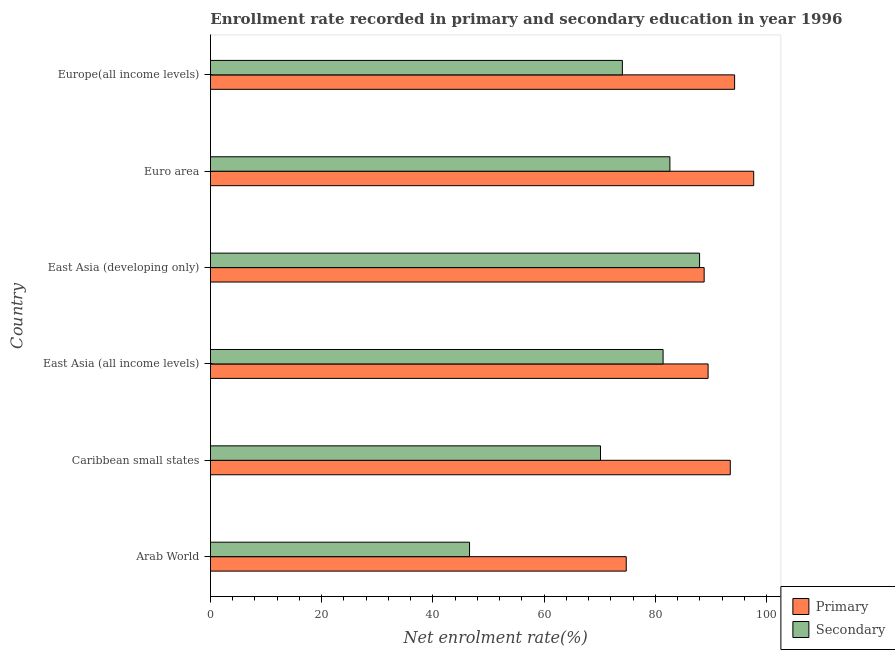Are the number of bars per tick equal to the number of legend labels?
Your answer should be very brief. Yes. How many bars are there on the 1st tick from the top?
Offer a terse response. 2. What is the label of the 3rd group of bars from the top?
Provide a short and direct response. East Asia (developing only). In how many cases, is the number of bars for a given country not equal to the number of legend labels?
Provide a succinct answer. 0. What is the enrollment rate in primary education in Caribbean small states?
Provide a succinct answer. 93.46. Across all countries, what is the maximum enrollment rate in secondary education?
Offer a terse response. 87.94. Across all countries, what is the minimum enrollment rate in primary education?
Make the answer very short. 74.76. In which country was the enrollment rate in secondary education maximum?
Your response must be concise. East Asia (developing only). In which country was the enrollment rate in primary education minimum?
Ensure brevity in your answer.  Arab World. What is the total enrollment rate in primary education in the graph?
Keep it short and to the point. 538.38. What is the difference between the enrollment rate in primary education in East Asia (developing only) and that in Euro area?
Your answer should be compact. -8.91. What is the difference between the enrollment rate in primary education in Euro area and the enrollment rate in secondary education in Europe(all income levels)?
Provide a succinct answer. 23.62. What is the average enrollment rate in secondary education per country?
Offer a terse response. 73.78. What is the difference between the enrollment rate in primary education and enrollment rate in secondary education in Arab World?
Provide a short and direct response. 28.18. In how many countries, is the enrollment rate in primary education greater than 40 %?
Offer a very short reply. 6. What is the ratio of the enrollment rate in primary education in East Asia (all income levels) to that in East Asia (developing only)?
Ensure brevity in your answer.  1.01. Is the enrollment rate in primary education in Arab World less than that in East Asia (developing only)?
Make the answer very short. Yes. What is the difference between the highest and the second highest enrollment rate in secondary education?
Offer a terse response. 5.34. What is the difference between the highest and the lowest enrollment rate in secondary education?
Make the answer very short. 41.36. What does the 2nd bar from the top in Arab World represents?
Offer a very short reply. Primary. What does the 2nd bar from the bottom in Arab World represents?
Your answer should be compact. Secondary. How many bars are there?
Make the answer very short. 12. Are all the bars in the graph horizontal?
Your answer should be compact. Yes. How many countries are there in the graph?
Ensure brevity in your answer.  6. What is the difference between two consecutive major ticks on the X-axis?
Make the answer very short. 20. Are the values on the major ticks of X-axis written in scientific E-notation?
Your response must be concise. No. Does the graph contain grids?
Make the answer very short. No. Where does the legend appear in the graph?
Your answer should be very brief. Bottom right. How many legend labels are there?
Provide a succinct answer. 2. How are the legend labels stacked?
Give a very brief answer. Vertical. What is the title of the graph?
Offer a very short reply. Enrollment rate recorded in primary and secondary education in year 1996. Does "Services" appear as one of the legend labels in the graph?
Offer a very short reply. No. What is the label or title of the X-axis?
Offer a very short reply. Net enrolment rate(%). What is the Net enrolment rate(%) in Primary in Arab World?
Provide a succinct answer. 74.76. What is the Net enrolment rate(%) of Secondary in Arab World?
Your response must be concise. 46.58. What is the Net enrolment rate(%) in Primary in Caribbean small states?
Ensure brevity in your answer.  93.46. What is the Net enrolment rate(%) in Secondary in Caribbean small states?
Your response must be concise. 70.13. What is the Net enrolment rate(%) in Primary in East Asia (all income levels)?
Your response must be concise. 89.47. What is the Net enrolment rate(%) in Secondary in East Asia (all income levels)?
Your answer should be compact. 81.38. What is the Net enrolment rate(%) in Primary in East Asia (developing only)?
Your answer should be very brief. 88.77. What is the Net enrolment rate(%) of Secondary in East Asia (developing only)?
Give a very brief answer. 87.94. What is the Net enrolment rate(%) of Primary in Euro area?
Your response must be concise. 97.68. What is the Net enrolment rate(%) of Secondary in Euro area?
Offer a terse response. 82.6. What is the Net enrolment rate(%) in Primary in Europe(all income levels)?
Ensure brevity in your answer.  94.24. What is the Net enrolment rate(%) in Secondary in Europe(all income levels)?
Ensure brevity in your answer.  74.06. Across all countries, what is the maximum Net enrolment rate(%) in Primary?
Give a very brief answer. 97.68. Across all countries, what is the maximum Net enrolment rate(%) of Secondary?
Give a very brief answer. 87.94. Across all countries, what is the minimum Net enrolment rate(%) of Primary?
Your response must be concise. 74.76. Across all countries, what is the minimum Net enrolment rate(%) of Secondary?
Keep it short and to the point. 46.58. What is the total Net enrolment rate(%) of Primary in the graph?
Your answer should be compact. 538.38. What is the total Net enrolment rate(%) of Secondary in the graph?
Your answer should be compact. 442.7. What is the difference between the Net enrolment rate(%) of Primary in Arab World and that in Caribbean small states?
Offer a very short reply. -18.7. What is the difference between the Net enrolment rate(%) of Secondary in Arab World and that in Caribbean small states?
Keep it short and to the point. -23.55. What is the difference between the Net enrolment rate(%) of Primary in Arab World and that in East Asia (all income levels)?
Your answer should be compact. -14.71. What is the difference between the Net enrolment rate(%) in Secondary in Arab World and that in East Asia (all income levels)?
Ensure brevity in your answer.  -34.8. What is the difference between the Net enrolment rate(%) of Primary in Arab World and that in East Asia (developing only)?
Your answer should be very brief. -14.01. What is the difference between the Net enrolment rate(%) of Secondary in Arab World and that in East Asia (developing only)?
Offer a terse response. -41.36. What is the difference between the Net enrolment rate(%) in Primary in Arab World and that in Euro area?
Your answer should be very brief. -22.92. What is the difference between the Net enrolment rate(%) of Secondary in Arab World and that in Euro area?
Keep it short and to the point. -36.02. What is the difference between the Net enrolment rate(%) in Primary in Arab World and that in Europe(all income levels)?
Your answer should be compact. -19.48. What is the difference between the Net enrolment rate(%) in Secondary in Arab World and that in Europe(all income levels)?
Make the answer very short. -27.48. What is the difference between the Net enrolment rate(%) of Primary in Caribbean small states and that in East Asia (all income levels)?
Keep it short and to the point. 3.99. What is the difference between the Net enrolment rate(%) in Secondary in Caribbean small states and that in East Asia (all income levels)?
Ensure brevity in your answer.  -11.25. What is the difference between the Net enrolment rate(%) of Primary in Caribbean small states and that in East Asia (developing only)?
Offer a terse response. 4.7. What is the difference between the Net enrolment rate(%) in Secondary in Caribbean small states and that in East Asia (developing only)?
Give a very brief answer. -17.82. What is the difference between the Net enrolment rate(%) in Primary in Caribbean small states and that in Euro area?
Keep it short and to the point. -4.21. What is the difference between the Net enrolment rate(%) in Secondary in Caribbean small states and that in Euro area?
Your answer should be compact. -12.48. What is the difference between the Net enrolment rate(%) in Primary in Caribbean small states and that in Europe(all income levels)?
Offer a very short reply. -0.78. What is the difference between the Net enrolment rate(%) in Secondary in Caribbean small states and that in Europe(all income levels)?
Your answer should be compact. -3.93. What is the difference between the Net enrolment rate(%) in Primary in East Asia (all income levels) and that in East Asia (developing only)?
Provide a short and direct response. 0.71. What is the difference between the Net enrolment rate(%) in Secondary in East Asia (all income levels) and that in East Asia (developing only)?
Your answer should be very brief. -6.56. What is the difference between the Net enrolment rate(%) of Primary in East Asia (all income levels) and that in Euro area?
Your answer should be very brief. -8.2. What is the difference between the Net enrolment rate(%) of Secondary in East Asia (all income levels) and that in Euro area?
Your answer should be compact. -1.22. What is the difference between the Net enrolment rate(%) in Primary in East Asia (all income levels) and that in Europe(all income levels)?
Provide a short and direct response. -4.77. What is the difference between the Net enrolment rate(%) in Secondary in East Asia (all income levels) and that in Europe(all income levels)?
Offer a terse response. 7.32. What is the difference between the Net enrolment rate(%) in Primary in East Asia (developing only) and that in Euro area?
Offer a very short reply. -8.91. What is the difference between the Net enrolment rate(%) of Secondary in East Asia (developing only) and that in Euro area?
Your response must be concise. 5.34. What is the difference between the Net enrolment rate(%) in Primary in East Asia (developing only) and that in Europe(all income levels)?
Your answer should be very brief. -5.48. What is the difference between the Net enrolment rate(%) in Secondary in East Asia (developing only) and that in Europe(all income levels)?
Keep it short and to the point. 13.88. What is the difference between the Net enrolment rate(%) in Primary in Euro area and that in Europe(all income levels)?
Ensure brevity in your answer.  3.43. What is the difference between the Net enrolment rate(%) in Secondary in Euro area and that in Europe(all income levels)?
Make the answer very short. 8.54. What is the difference between the Net enrolment rate(%) in Primary in Arab World and the Net enrolment rate(%) in Secondary in Caribbean small states?
Make the answer very short. 4.63. What is the difference between the Net enrolment rate(%) of Primary in Arab World and the Net enrolment rate(%) of Secondary in East Asia (all income levels)?
Keep it short and to the point. -6.62. What is the difference between the Net enrolment rate(%) in Primary in Arab World and the Net enrolment rate(%) in Secondary in East Asia (developing only)?
Your answer should be compact. -13.19. What is the difference between the Net enrolment rate(%) of Primary in Arab World and the Net enrolment rate(%) of Secondary in Euro area?
Give a very brief answer. -7.85. What is the difference between the Net enrolment rate(%) in Primary in Arab World and the Net enrolment rate(%) in Secondary in Europe(all income levels)?
Offer a very short reply. 0.7. What is the difference between the Net enrolment rate(%) in Primary in Caribbean small states and the Net enrolment rate(%) in Secondary in East Asia (all income levels)?
Offer a very short reply. 12.08. What is the difference between the Net enrolment rate(%) in Primary in Caribbean small states and the Net enrolment rate(%) in Secondary in East Asia (developing only)?
Your answer should be compact. 5.52. What is the difference between the Net enrolment rate(%) of Primary in Caribbean small states and the Net enrolment rate(%) of Secondary in Euro area?
Offer a terse response. 10.86. What is the difference between the Net enrolment rate(%) in Primary in Caribbean small states and the Net enrolment rate(%) in Secondary in Europe(all income levels)?
Give a very brief answer. 19.4. What is the difference between the Net enrolment rate(%) in Primary in East Asia (all income levels) and the Net enrolment rate(%) in Secondary in East Asia (developing only)?
Ensure brevity in your answer.  1.53. What is the difference between the Net enrolment rate(%) of Primary in East Asia (all income levels) and the Net enrolment rate(%) of Secondary in Euro area?
Offer a terse response. 6.87. What is the difference between the Net enrolment rate(%) of Primary in East Asia (all income levels) and the Net enrolment rate(%) of Secondary in Europe(all income levels)?
Provide a short and direct response. 15.41. What is the difference between the Net enrolment rate(%) in Primary in East Asia (developing only) and the Net enrolment rate(%) in Secondary in Euro area?
Offer a very short reply. 6.16. What is the difference between the Net enrolment rate(%) in Primary in East Asia (developing only) and the Net enrolment rate(%) in Secondary in Europe(all income levels)?
Your answer should be very brief. 14.71. What is the difference between the Net enrolment rate(%) of Primary in Euro area and the Net enrolment rate(%) of Secondary in Europe(all income levels)?
Offer a terse response. 23.61. What is the average Net enrolment rate(%) in Primary per country?
Make the answer very short. 89.73. What is the average Net enrolment rate(%) of Secondary per country?
Keep it short and to the point. 73.78. What is the difference between the Net enrolment rate(%) in Primary and Net enrolment rate(%) in Secondary in Arab World?
Ensure brevity in your answer.  28.17. What is the difference between the Net enrolment rate(%) of Primary and Net enrolment rate(%) of Secondary in Caribbean small states?
Offer a terse response. 23.33. What is the difference between the Net enrolment rate(%) in Primary and Net enrolment rate(%) in Secondary in East Asia (all income levels)?
Offer a terse response. 8.09. What is the difference between the Net enrolment rate(%) in Primary and Net enrolment rate(%) in Secondary in East Asia (developing only)?
Your response must be concise. 0.82. What is the difference between the Net enrolment rate(%) of Primary and Net enrolment rate(%) of Secondary in Euro area?
Provide a short and direct response. 15.07. What is the difference between the Net enrolment rate(%) in Primary and Net enrolment rate(%) in Secondary in Europe(all income levels)?
Make the answer very short. 20.18. What is the ratio of the Net enrolment rate(%) of Primary in Arab World to that in Caribbean small states?
Your answer should be compact. 0.8. What is the ratio of the Net enrolment rate(%) of Secondary in Arab World to that in Caribbean small states?
Offer a very short reply. 0.66. What is the ratio of the Net enrolment rate(%) of Primary in Arab World to that in East Asia (all income levels)?
Your response must be concise. 0.84. What is the ratio of the Net enrolment rate(%) of Secondary in Arab World to that in East Asia (all income levels)?
Your answer should be very brief. 0.57. What is the ratio of the Net enrolment rate(%) in Primary in Arab World to that in East Asia (developing only)?
Your response must be concise. 0.84. What is the ratio of the Net enrolment rate(%) of Secondary in Arab World to that in East Asia (developing only)?
Keep it short and to the point. 0.53. What is the ratio of the Net enrolment rate(%) in Primary in Arab World to that in Euro area?
Your answer should be compact. 0.77. What is the ratio of the Net enrolment rate(%) of Secondary in Arab World to that in Euro area?
Ensure brevity in your answer.  0.56. What is the ratio of the Net enrolment rate(%) in Primary in Arab World to that in Europe(all income levels)?
Offer a very short reply. 0.79. What is the ratio of the Net enrolment rate(%) of Secondary in Arab World to that in Europe(all income levels)?
Keep it short and to the point. 0.63. What is the ratio of the Net enrolment rate(%) of Primary in Caribbean small states to that in East Asia (all income levels)?
Your answer should be compact. 1.04. What is the ratio of the Net enrolment rate(%) in Secondary in Caribbean small states to that in East Asia (all income levels)?
Ensure brevity in your answer.  0.86. What is the ratio of the Net enrolment rate(%) in Primary in Caribbean small states to that in East Asia (developing only)?
Make the answer very short. 1.05. What is the ratio of the Net enrolment rate(%) of Secondary in Caribbean small states to that in East Asia (developing only)?
Offer a very short reply. 0.8. What is the ratio of the Net enrolment rate(%) of Primary in Caribbean small states to that in Euro area?
Your answer should be compact. 0.96. What is the ratio of the Net enrolment rate(%) in Secondary in Caribbean small states to that in Euro area?
Your response must be concise. 0.85. What is the ratio of the Net enrolment rate(%) of Primary in Caribbean small states to that in Europe(all income levels)?
Provide a short and direct response. 0.99. What is the ratio of the Net enrolment rate(%) of Secondary in Caribbean small states to that in Europe(all income levels)?
Ensure brevity in your answer.  0.95. What is the ratio of the Net enrolment rate(%) of Secondary in East Asia (all income levels) to that in East Asia (developing only)?
Provide a succinct answer. 0.93. What is the ratio of the Net enrolment rate(%) of Primary in East Asia (all income levels) to that in Euro area?
Keep it short and to the point. 0.92. What is the ratio of the Net enrolment rate(%) in Secondary in East Asia (all income levels) to that in Euro area?
Provide a short and direct response. 0.99. What is the ratio of the Net enrolment rate(%) in Primary in East Asia (all income levels) to that in Europe(all income levels)?
Provide a short and direct response. 0.95. What is the ratio of the Net enrolment rate(%) of Secondary in East Asia (all income levels) to that in Europe(all income levels)?
Provide a succinct answer. 1.1. What is the ratio of the Net enrolment rate(%) in Primary in East Asia (developing only) to that in Euro area?
Your answer should be very brief. 0.91. What is the ratio of the Net enrolment rate(%) in Secondary in East Asia (developing only) to that in Euro area?
Give a very brief answer. 1.06. What is the ratio of the Net enrolment rate(%) of Primary in East Asia (developing only) to that in Europe(all income levels)?
Your answer should be very brief. 0.94. What is the ratio of the Net enrolment rate(%) of Secondary in East Asia (developing only) to that in Europe(all income levels)?
Offer a terse response. 1.19. What is the ratio of the Net enrolment rate(%) of Primary in Euro area to that in Europe(all income levels)?
Make the answer very short. 1.04. What is the ratio of the Net enrolment rate(%) of Secondary in Euro area to that in Europe(all income levels)?
Your answer should be compact. 1.12. What is the difference between the highest and the second highest Net enrolment rate(%) in Primary?
Your answer should be compact. 3.43. What is the difference between the highest and the second highest Net enrolment rate(%) of Secondary?
Provide a succinct answer. 5.34. What is the difference between the highest and the lowest Net enrolment rate(%) of Primary?
Give a very brief answer. 22.92. What is the difference between the highest and the lowest Net enrolment rate(%) of Secondary?
Make the answer very short. 41.36. 